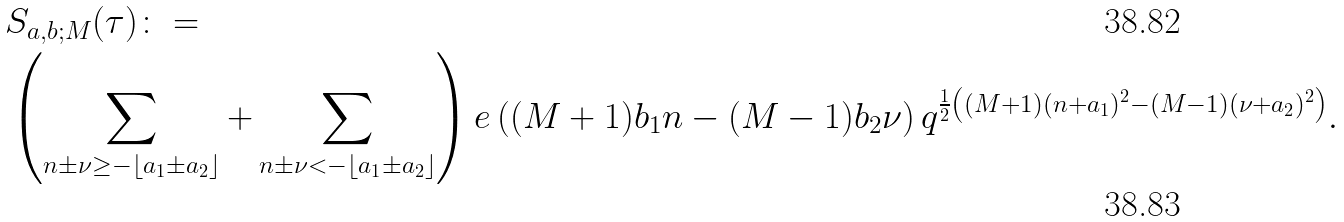Convert formula to latex. <formula><loc_0><loc_0><loc_500><loc_500>& S _ { a , b ; M } ( \tau ) \colon = \\ & \left ( \sum _ { n \pm \nu \geq - \lfloor a _ { 1 } \pm a _ { 2 } \rfloor } + \sum _ { n \pm \nu < - \lfloor a _ { 1 } \pm a _ { 2 } \rfloor } \right ) e \left ( ( M + 1 ) b _ { 1 } n - ( M - 1 ) b _ { 2 } \nu \right ) q ^ { \frac { 1 } { 2 } \left ( ( M + 1 ) ( n + a _ { 1 } ) ^ { 2 } - ( M - 1 ) ( \nu + a _ { 2 } ) ^ { 2 } \right ) } .</formula> 